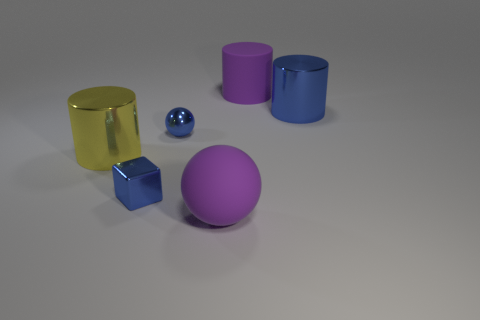There is a large thing that is the same color as the big rubber cylinder; what is its material?
Your answer should be very brief. Rubber. What size is the purple thing in front of the small blue metallic ball?
Your response must be concise. Large. There is a matte object on the right side of the purple object in front of the big blue metal cylinder; what shape is it?
Offer a terse response. Cylinder. The other large metal thing that is the same shape as the yellow object is what color?
Make the answer very short. Blue. There is a sphere on the right side of the blue ball; is its size the same as the blue sphere?
Provide a succinct answer. No. The big shiny object that is the same color as the metal ball is what shape?
Provide a succinct answer. Cylinder. How many small balls are the same material as the purple cylinder?
Offer a very short reply. 0. The blue cylinder that is to the right of the cylinder that is behind the shiny object that is to the right of the purple sphere is made of what material?
Provide a short and direct response. Metal. There is a large matte object that is behind the blue thing behind the small shiny ball; what color is it?
Provide a succinct answer. Purple. There is a matte cylinder that is the same size as the purple sphere; what color is it?
Provide a short and direct response. Purple. 